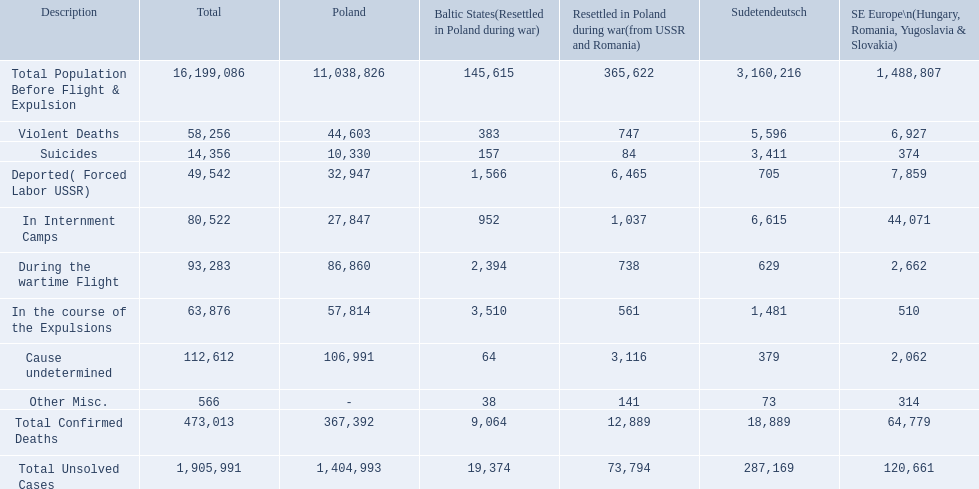In the baltic states, what was the overall number of confirmed deaths? 9,064. How many deaths had an indeterminate cause? 64. How many deaths in that region fell under the miscellaneous category? 38. Which had a higher count, deaths with an undetermined cause or miscellaneous deaths? Cause undetermined. 